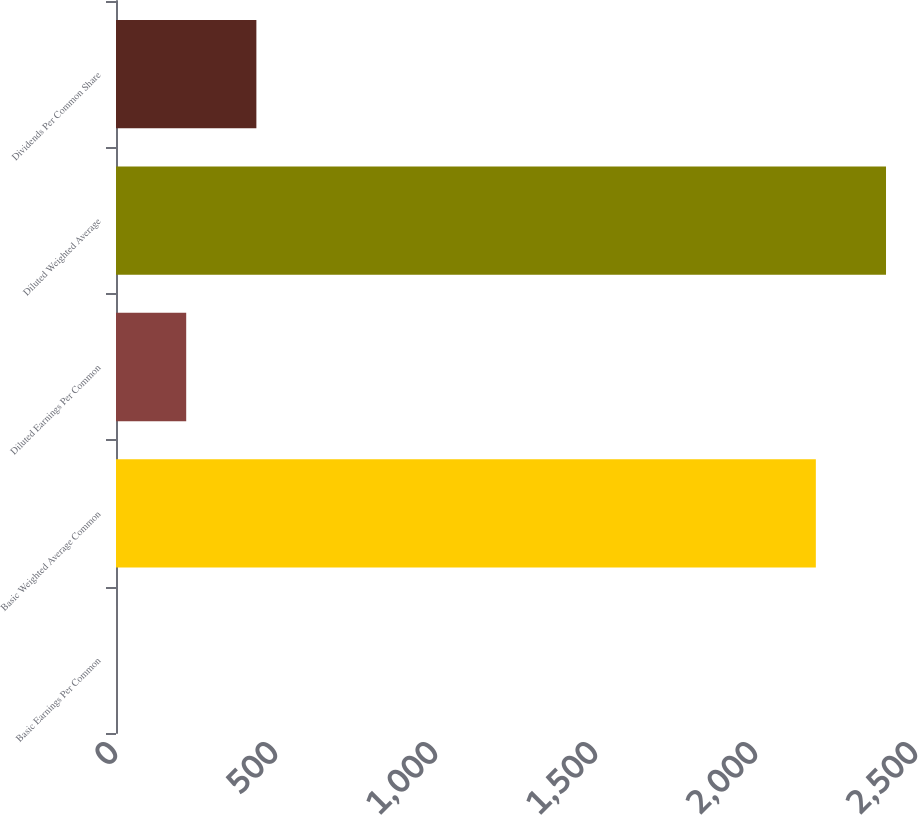Convert chart to OTSL. <chart><loc_0><loc_0><loc_500><loc_500><bar_chart><fcel>Basic Earnings Per Common<fcel>Basic Weighted Average Common<fcel>Diluted Earnings Per Common<fcel>Diluted Weighted Average<fcel>Dividends Per Common Share<nl><fcel>0.1<fcel>2187<fcel>219.39<fcel>2406.29<fcel>438.68<nl></chart> 